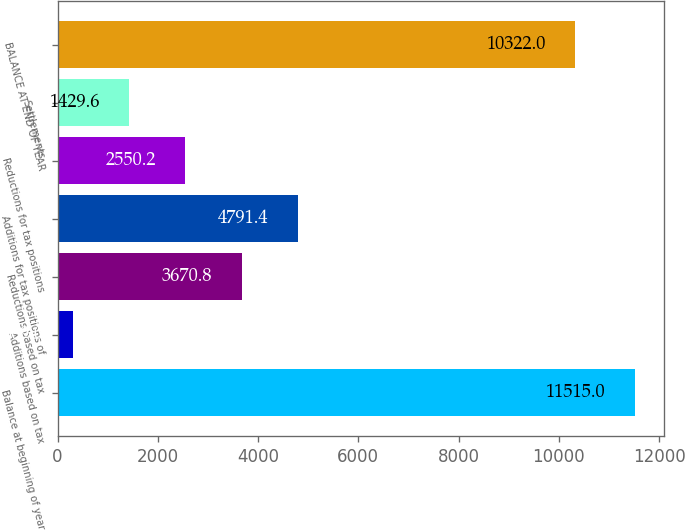Convert chart. <chart><loc_0><loc_0><loc_500><loc_500><bar_chart><fcel>Balance at beginning of year<fcel>Additions based on tax<fcel>Reductions based on tax<fcel>Additions for tax positions of<fcel>Reductions for tax positions<fcel>Settlements<fcel>BALANCE AT END OF YEAR<nl><fcel>11515<fcel>309<fcel>3670.8<fcel>4791.4<fcel>2550.2<fcel>1429.6<fcel>10322<nl></chart> 